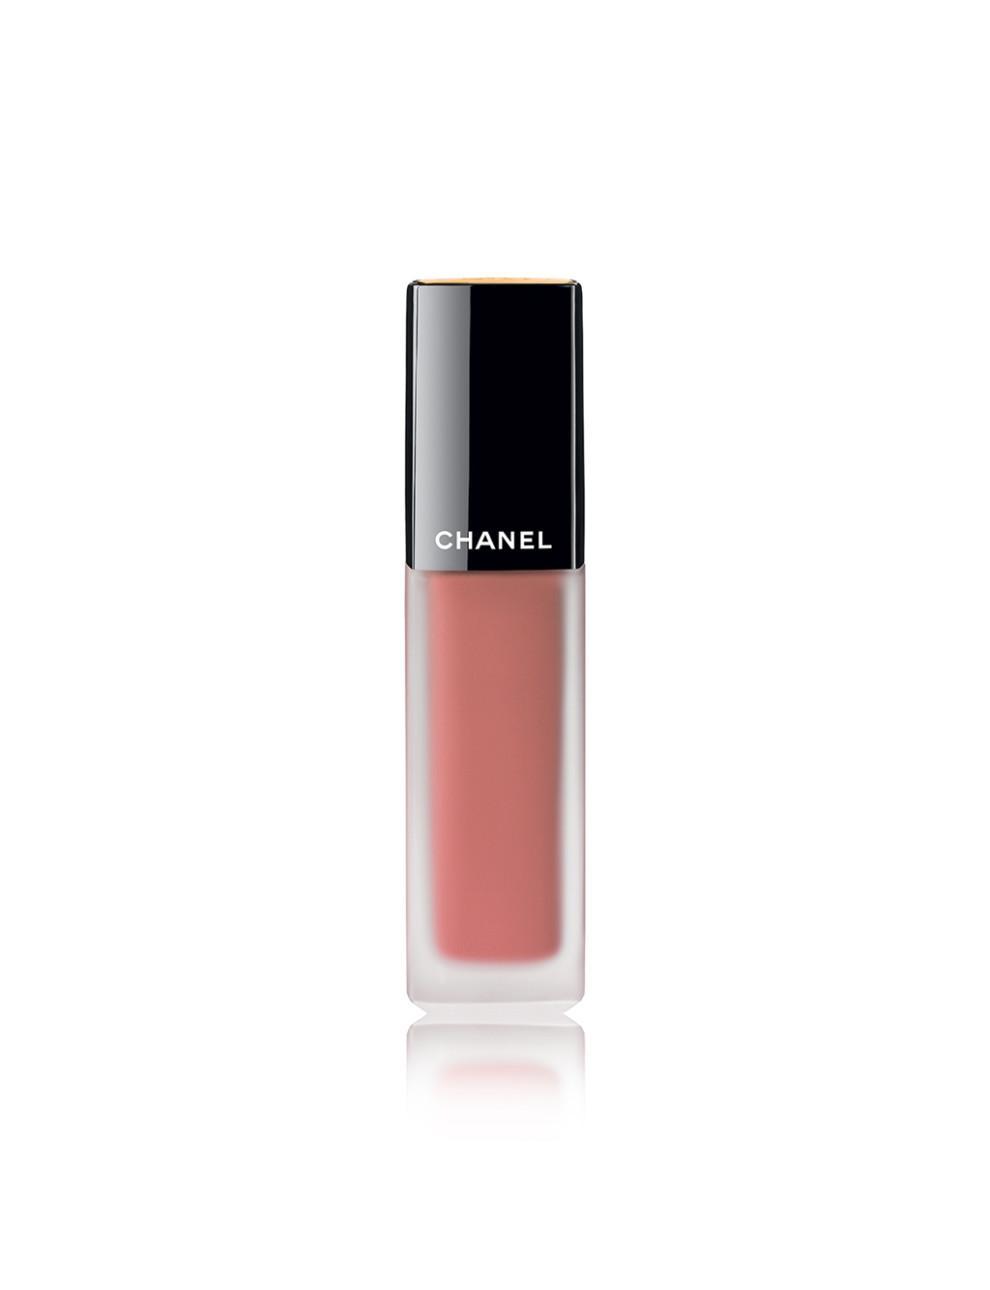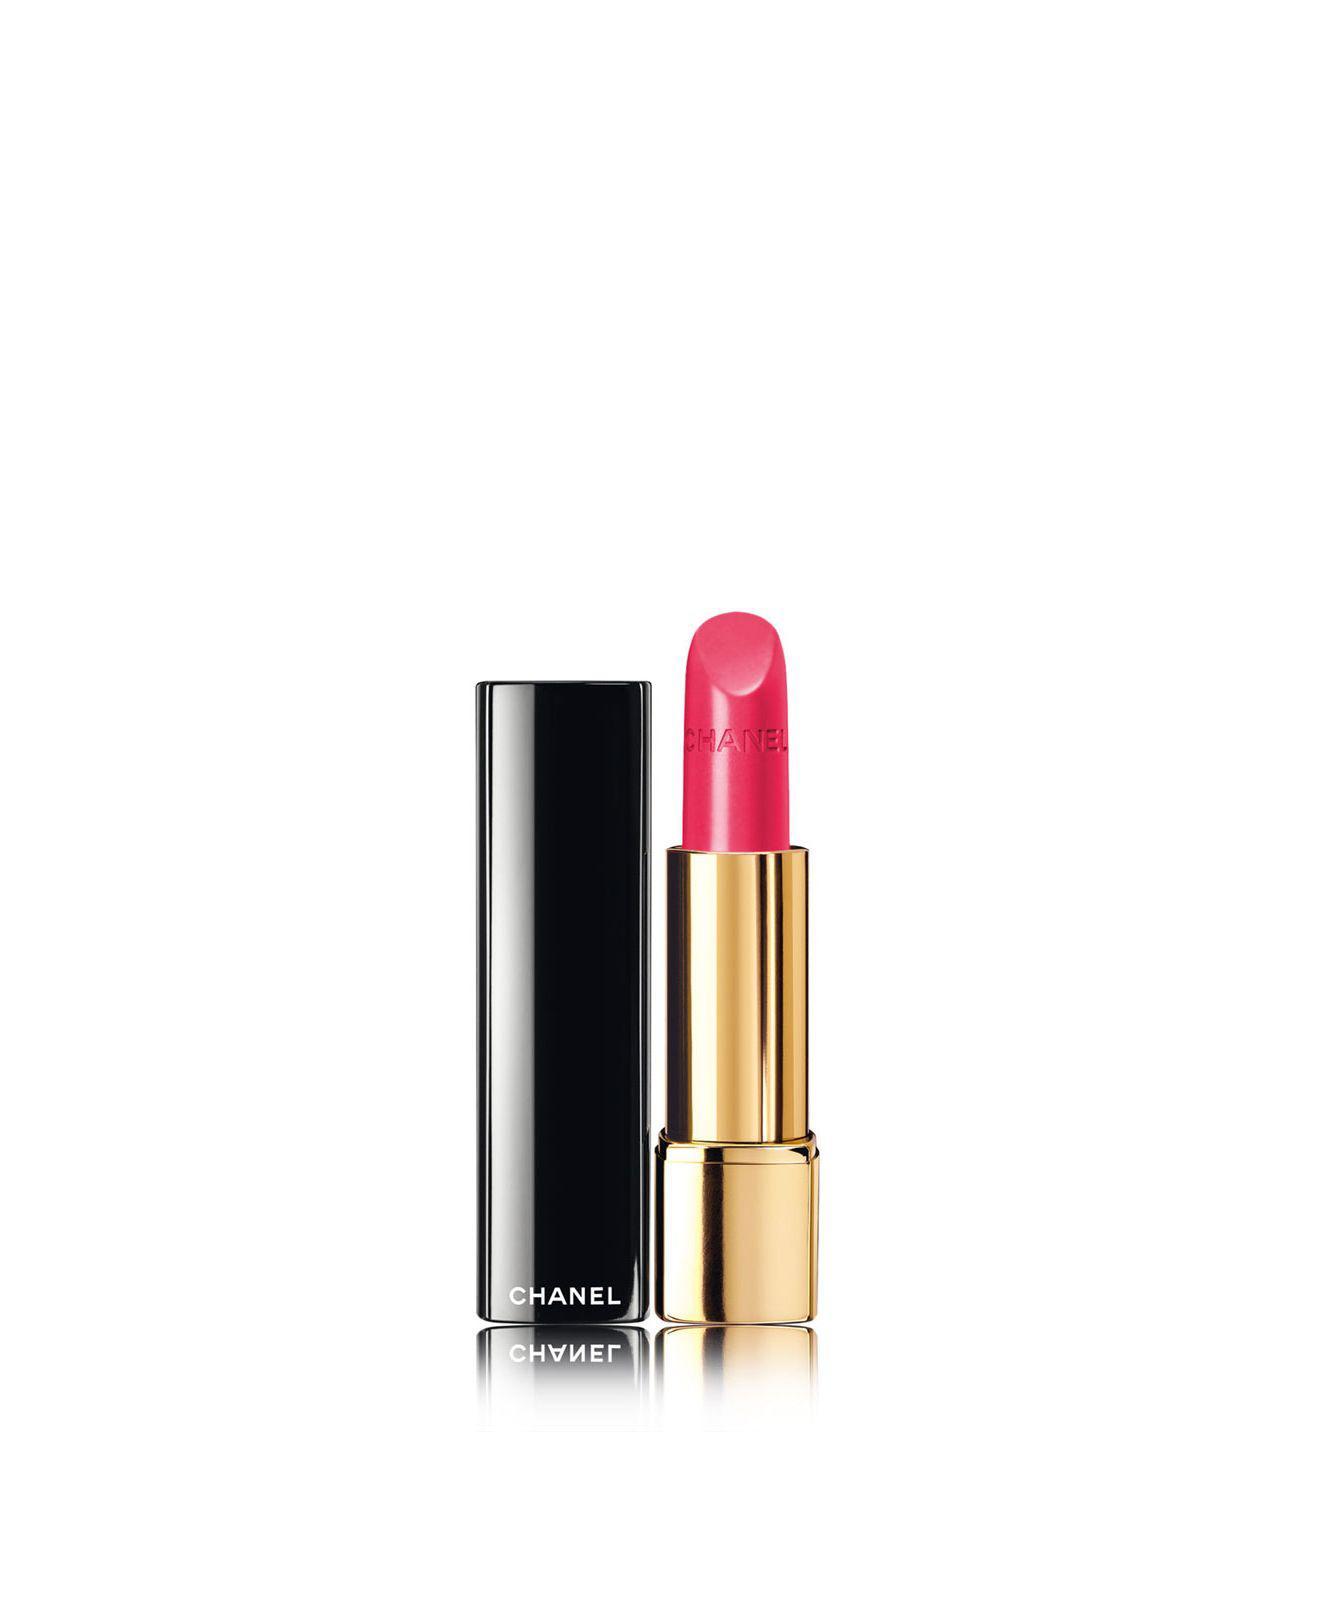The first image is the image on the left, the second image is the image on the right. Analyze the images presented: Is the assertion "One lipstick is extended to show its color with its cap sitting beside it, while a second lipstick is closed, but with a visible color." valid? Answer yes or no. Yes. The first image is the image on the left, the second image is the image on the right. Assess this claim about the two images: "An image features one orange lipstick standing next to its upright lid.". Correct or not? Answer yes or no. No. 